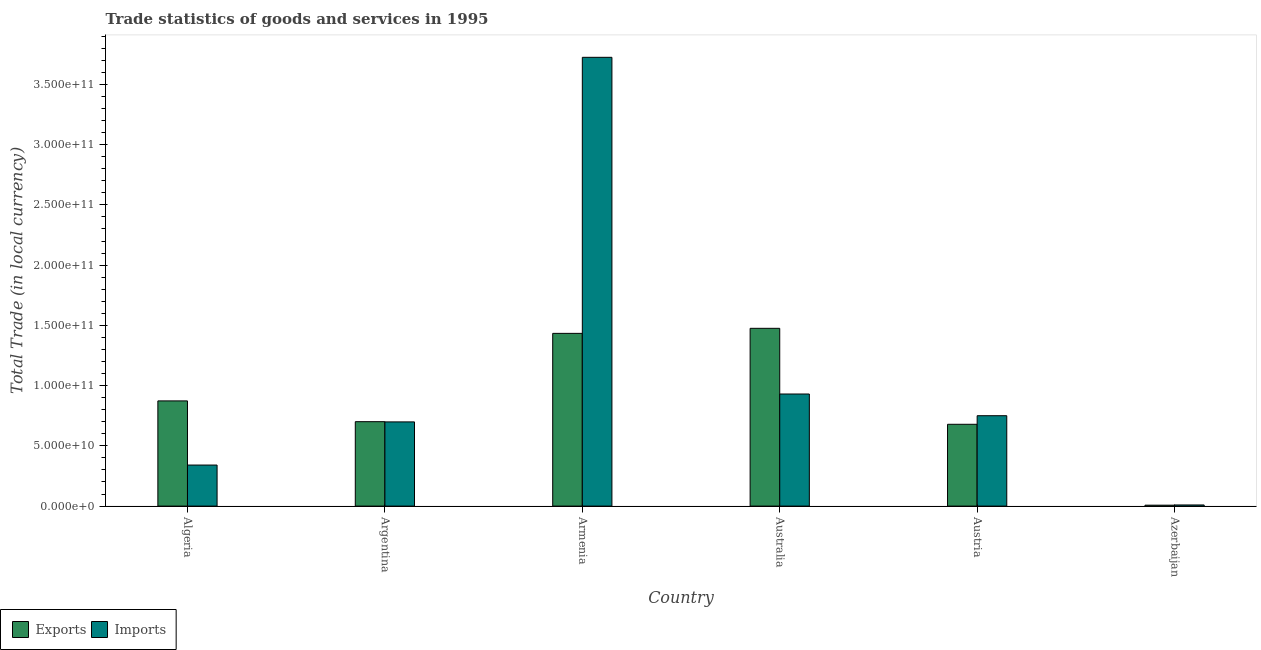How many different coloured bars are there?
Provide a short and direct response. 2. Are the number of bars per tick equal to the number of legend labels?
Provide a short and direct response. Yes. In how many cases, is the number of bars for a given country not equal to the number of legend labels?
Offer a terse response. 0. What is the imports of goods and services in Algeria?
Ensure brevity in your answer.  3.41e+1. Across all countries, what is the maximum imports of goods and services?
Offer a terse response. 3.72e+11. Across all countries, what is the minimum export of goods and services?
Your response must be concise. 7.61e+08. In which country was the export of goods and services minimum?
Your response must be concise. Azerbaijan. What is the total imports of goods and services in the graph?
Keep it short and to the point. 6.45e+11. What is the difference between the imports of goods and services in Argentina and that in Azerbaijan?
Your answer should be compact. 6.89e+1. What is the difference between the export of goods and services in Australia and the imports of goods and services in Austria?
Ensure brevity in your answer.  7.25e+1. What is the average imports of goods and services per country?
Give a very brief answer. 1.08e+11. What is the difference between the export of goods and services and imports of goods and services in Austria?
Keep it short and to the point. -7.12e+09. In how many countries, is the imports of goods and services greater than 10000000000 LCU?
Your response must be concise. 5. What is the ratio of the imports of goods and services in Algeria to that in Australia?
Make the answer very short. 0.37. Is the imports of goods and services in Argentina less than that in Australia?
Your answer should be compact. Yes. Is the difference between the imports of goods and services in Algeria and Australia greater than the difference between the export of goods and services in Algeria and Australia?
Make the answer very short. Yes. What is the difference between the highest and the second highest imports of goods and services?
Give a very brief answer. 2.79e+11. What is the difference between the highest and the lowest export of goods and services?
Your response must be concise. 1.47e+11. Is the sum of the imports of goods and services in Algeria and Austria greater than the maximum export of goods and services across all countries?
Make the answer very short. No. What does the 2nd bar from the left in Austria represents?
Provide a short and direct response. Imports. What does the 1st bar from the right in Australia represents?
Keep it short and to the point. Imports. How many bars are there?
Give a very brief answer. 12. What is the difference between two consecutive major ticks on the Y-axis?
Keep it short and to the point. 5.00e+1. What is the title of the graph?
Ensure brevity in your answer.  Trade statistics of goods and services in 1995. What is the label or title of the Y-axis?
Provide a short and direct response. Total Trade (in local currency). What is the Total Trade (in local currency) of Exports in Algeria?
Your answer should be very brief. 8.73e+1. What is the Total Trade (in local currency) in Imports in Algeria?
Give a very brief answer. 3.41e+1. What is the Total Trade (in local currency) of Exports in Argentina?
Give a very brief answer. 7.01e+1. What is the Total Trade (in local currency) in Imports in Argentina?
Keep it short and to the point. 6.99e+1. What is the Total Trade (in local currency) in Exports in Armenia?
Make the answer very short. 1.43e+11. What is the Total Trade (in local currency) of Imports in Armenia?
Keep it short and to the point. 3.72e+11. What is the Total Trade (in local currency) in Exports in Australia?
Provide a succinct answer. 1.48e+11. What is the Total Trade (in local currency) in Imports in Australia?
Your response must be concise. 9.30e+1. What is the Total Trade (in local currency) in Exports in Austria?
Keep it short and to the point. 6.79e+1. What is the Total Trade (in local currency) of Imports in Austria?
Keep it short and to the point. 7.50e+1. What is the Total Trade (in local currency) in Exports in Azerbaijan?
Offer a very short reply. 7.61e+08. What is the Total Trade (in local currency) in Imports in Azerbaijan?
Make the answer very short. 9.42e+08. Across all countries, what is the maximum Total Trade (in local currency) of Exports?
Give a very brief answer. 1.48e+11. Across all countries, what is the maximum Total Trade (in local currency) of Imports?
Provide a succinct answer. 3.72e+11. Across all countries, what is the minimum Total Trade (in local currency) of Exports?
Give a very brief answer. 7.61e+08. Across all countries, what is the minimum Total Trade (in local currency) of Imports?
Keep it short and to the point. 9.42e+08. What is the total Total Trade (in local currency) in Exports in the graph?
Provide a short and direct response. 5.17e+11. What is the total Total Trade (in local currency) of Imports in the graph?
Keep it short and to the point. 6.45e+11. What is the difference between the Total Trade (in local currency) of Exports in Algeria and that in Argentina?
Keep it short and to the point. 1.72e+1. What is the difference between the Total Trade (in local currency) in Imports in Algeria and that in Argentina?
Keep it short and to the point. -3.58e+1. What is the difference between the Total Trade (in local currency) of Exports in Algeria and that in Armenia?
Make the answer very short. -5.60e+1. What is the difference between the Total Trade (in local currency) in Imports in Algeria and that in Armenia?
Your answer should be very brief. -3.38e+11. What is the difference between the Total Trade (in local currency) in Exports in Algeria and that in Australia?
Make the answer very short. -6.02e+1. What is the difference between the Total Trade (in local currency) of Imports in Algeria and that in Australia?
Your response must be concise. -5.90e+1. What is the difference between the Total Trade (in local currency) in Exports in Algeria and that in Austria?
Offer a very short reply. 1.94e+1. What is the difference between the Total Trade (in local currency) in Imports in Algeria and that in Austria?
Ensure brevity in your answer.  -4.09e+1. What is the difference between the Total Trade (in local currency) of Exports in Algeria and that in Azerbaijan?
Your answer should be compact. 8.65e+1. What is the difference between the Total Trade (in local currency) of Imports in Algeria and that in Azerbaijan?
Provide a succinct answer. 3.31e+1. What is the difference between the Total Trade (in local currency) in Exports in Argentina and that in Armenia?
Offer a terse response. -7.33e+1. What is the difference between the Total Trade (in local currency) of Imports in Argentina and that in Armenia?
Offer a very short reply. -3.03e+11. What is the difference between the Total Trade (in local currency) of Exports in Argentina and that in Australia?
Offer a terse response. -7.75e+1. What is the difference between the Total Trade (in local currency) in Imports in Argentina and that in Australia?
Your answer should be compact. -2.31e+1. What is the difference between the Total Trade (in local currency) in Exports in Argentina and that in Austria?
Your response must be concise. 2.18e+09. What is the difference between the Total Trade (in local currency) in Imports in Argentina and that in Austria?
Keep it short and to the point. -5.14e+09. What is the difference between the Total Trade (in local currency) in Exports in Argentina and that in Azerbaijan?
Keep it short and to the point. 6.93e+1. What is the difference between the Total Trade (in local currency) of Imports in Argentina and that in Azerbaijan?
Give a very brief answer. 6.89e+1. What is the difference between the Total Trade (in local currency) of Exports in Armenia and that in Australia?
Offer a terse response. -4.19e+09. What is the difference between the Total Trade (in local currency) in Imports in Armenia and that in Australia?
Provide a short and direct response. 2.79e+11. What is the difference between the Total Trade (in local currency) of Exports in Armenia and that in Austria?
Your answer should be very brief. 7.55e+1. What is the difference between the Total Trade (in local currency) of Imports in Armenia and that in Austria?
Offer a very short reply. 2.97e+11. What is the difference between the Total Trade (in local currency) in Exports in Armenia and that in Azerbaijan?
Make the answer very short. 1.43e+11. What is the difference between the Total Trade (in local currency) in Imports in Armenia and that in Azerbaijan?
Give a very brief answer. 3.72e+11. What is the difference between the Total Trade (in local currency) of Exports in Australia and that in Austria?
Your answer should be compact. 7.96e+1. What is the difference between the Total Trade (in local currency) in Imports in Australia and that in Austria?
Provide a short and direct response. 1.80e+1. What is the difference between the Total Trade (in local currency) in Exports in Australia and that in Azerbaijan?
Your response must be concise. 1.47e+11. What is the difference between the Total Trade (in local currency) of Imports in Australia and that in Azerbaijan?
Provide a short and direct response. 9.21e+1. What is the difference between the Total Trade (in local currency) of Exports in Austria and that in Azerbaijan?
Give a very brief answer. 6.71e+1. What is the difference between the Total Trade (in local currency) in Imports in Austria and that in Azerbaijan?
Provide a short and direct response. 7.41e+1. What is the difference between the Total Trade (in local currency) in Exports in Algeria and the Total Trade (in local currency) in Imports in Argentina?
Your answer should be compact. 1.74e+1. What is the difference between the Total Trade (in local currency) in Exports in Algeria and the Total Trade (in local currency) in Imports in Armenia?
Give a very brief answer. -2.85e+11. What is the difference between the Total Trade (in local currency) of Exports in Algeria and the Total Trade (in local currency) of Imports in Australia?
Make the answer very short. -5.72e+09. What is the difference between the Total Trade (in local currency) of Exports in Algeria and the Total Trade (in local currency) of Imports in Austria?
Your answer should be very brief. 1.23e+1. What is the difference between the Total Trade (in local currency) in Exports in Algeria and the Total Trade (in local currency) in Imports in Azerbaijan?
Offer a very short reply. 8.64e+1. What is the difference between the Total Trade (in local currency) of Exports in Argentina and the Total Trade (in local currency) of Imports in Armenia?
Provide a short and direct response. -3.02e+11. What is the difference between the Total Trade (in local currency) of Exports in Argentina and the Total Trade (in local currency) of Imports in Australia?
Make the answer very short. -2.30e+1. What is the difference between the Total Trade (in local currency) in Exports in Argentina and the Total Trade (in local currency) in Imports in Austria?
Your answer should be compact. -4.95e+09. What is the difference between the Total Trade (in local currency) in Exports in Argentina and the Total Trade (in local currency) in Imports in Azerbaijan?
Your answer should be compact. 6.91e+1. What is the difference between the Total Trade (in local currency) in Exports in Armenia and the Total Trade (in local currency) in Imports in Australia?
Your answer should be very brief. 5.03e+1. What is the difference between the Total Trade (in local currency) in Exports in Armenia and the Total Trade (in local currency) in Imports in Austria?
Offer a terse response. 6.83e+1. What is the difference between the Total Trade (in local currency) of Exports in Armenia and the Total Trade (in local currency) of Imports in Azerbaijan?
Make the answer very short. 1.42e+11. What is the difference between the Total Trade (in local currency) of Exports in Australia and the Total Trade (in local currency) of Imports in Austria?
Keep it short and to the point. 7.25e+1. What is the difference between the Total Trade (in local currency) of Exports in Australia and the Total Trade (in local currency) of Imports in Azerbaijan?
Provide a short and direct response. 1.47e+11. What is the difference between the Total Trade (in local currency) in Exports in Austria and the Total Trade (in local currency) in Imports in Azerbaijan?
Provide a succinct answer. 6.69e+1. What is the average Total Trade (in local currency) in Exports per country?
Provide a short and direct response. 8.61e+1. What is the average Total Trade (in local currency) of Imports per country?
Provide a succinct answer. 1.08e+11. What is the difference between the Total Trade (in local currency) in Exports and Total Trade (in local currency) in Imports in Algeria?
Your answer should be compact. 5.32e+1. What is the difference between the Total Trade (in local currency) in Exports and Total Trade (in local currency) in Imports in Argentina?
Provide a short and direct response. 1.91e+08. What is the difference between the Total Trade (in local currency) of Exports and Total Trade (in local currency) of Imports in Armenia?
Your answer should be very brief. -2.29e+11. What is the difference between the Total Trade (in local currency) in Exports and Total Trade (in local currency) in Imports in Australia?
Make the answer very short. 5.45e+1. What is the difference between the Total Trade (in local currency) in Exports and Total Trade (in local currency) in Imports in Austria?
Offer a terse response. -7.12e+09. What is the difference between the Total Trade (in local currency) in Exports and Total Trade (in local currency) in Imports in Azerbaijan?
Provide a short and direct response. -1.81e+08. What is the ratio of the Total Trade (in local currency) in Exports in Algeria to that in Argentina?
Keep it short and to the point. 1.25. What is the ratio of the Total Trade (in local currency) of Imports in Algeria to that in Argentina?
Offer a very short reply. 0.49. What is the ratio of the Total Trade (in local currency) of Exports in Algeria to that in Armenia?
Your answer should be compact. 0.61. What is the ratio of the Total Trade (in local currency) of Imports in Algeria to that in Armenia?
Provide a short and direct response. 0.09. What is the ratio of the Total Trade (in local currency) in Exports in Algeria to that in Australia?
Offer a very short reply. 0.59. What is the ratio of the Total Trade (in local currency) in Imports in Algeria to that in Australia?
Provide a succinct answer. 0.37. What is the ratio of the Total Trade (in local currency) of Exports in Algeria to that in Austria?
Your answer should be compact. 1.29. What is the ratio of the Total Trade (in local currency) in Imports in Algeria to that in Austria?
Ensure brevity in your answer.  0.45. What is the ratio of the Total Trade (in local currency) of Exports in Algeria to that in Azerbaijan?
Your answer should be compact. 114.74. What is the ratio of the Total Trade (in local currency) in Imports in Algeria to that in Azerbaijan?
Provide a short and direct response. 36.18. What is the ratio of the Total Trade (in local currency) in Exports in Argentina to that in Armenia?
Your answer should be compact. 0.49. What is the ratio of the Total Trade (in local currency) of Imports in Argentina to that in Armenia?
Give a very brief answer. 0.19. What is the ratio of the Total Trade (in local currency) in Exports in Argentina to that in Australia?
Your answer should be very brief. 0.47. What is the ratio of the Total Trade (in local currency) in Imports in Argentina to that in Australia?
Give a very brief answer. 0.75. What is the ratio of the Total Trade (in local currency) of Exports in Argentina to that in Austria?
Ensure brevity in your answer.  1.03. What is the ratio of the Total Trade (in local currency) in Imports in Argentina to that in Austria?
Offer a very short reply. 0.93. What is the ratio of the Total Trade (in local currency) of Exports in Argentina to that in Azerbaijan?
Keep it short and to the point. 92.09. What is the ratio of the Total Trade (in local currency) in Imports in Argentina to that in Azerbaijan?
Provide a succinct answer. 74.21. What is the ratio of the Total Trade (in local currency) of Exports in Armenia to that in Australia?
Make the answer very short. 0.97. What is the ratio of the Total Trade (in local currency) in Imports in Armenia to that in Australia?
Your response must be concise. 4. What is the ratio of the Total Trade (in local currency) of Exports in Armenia to that in Austria?
Your answer should be very brief. 2.11. What is the ratio of the Total Trade (in local currency) of Imports in Armenia to that in Austria?
Provide a succinct answer. 4.97. What is the ratio of the Total Trade (in local currency) of Exports in Armenia to that in Azerbaijan?
Offer a terse response. 188.4. What is the ratio of the Total Trade (in local currency) in Imports in Armenia to that in Azerbaijan?
Your answer should be compact. 395.56. What is the ratio of the Total Trade (in local currency) in Exports in Australia to that in Austria?
Provide a short and direct response. 2.17. What is the ratio of the Total Trade (in local currency) in Imports in Australia to that in Austria?
Keep it short and to the point. 1.24. What is the ratio of the Total Trade (in local currency) in Exports in Australia to that in Azerbaijan?
Offer a very short reply. 193.9. What is the ratio of the Total Trade (in local currency) of Imports in Australia to that in Azerbaijan?
Your answer should be very brief. 98.79. What is the ratio of the Total Trade (in local currency) in Exports in Austria to that in Azerbaijan?
Make the answer very short. 89.23. What is the ratio of the Total Trade (in local currency) of Imports in Austria to that in Azerbaijan?
Provide a short and direct response. 79.67. What is the difference between the highest and the second highest Total Trade (in local currency) in Exports?
Give a very brief answer. 4.19e+09. What is the difference between the highest and the second highest Total Trade (in local currency) of Imports?
Make the answer very short. 2.79e+11. What is the difference between the highest and the lowest Total Trade (in local currency) in Exports?
Give a very brief answer. 1.47e+11. What is the difference between the highest and the lowest Total Trade (in local currency) of Imports?
Give a very brief answer. 3.72e+11. 